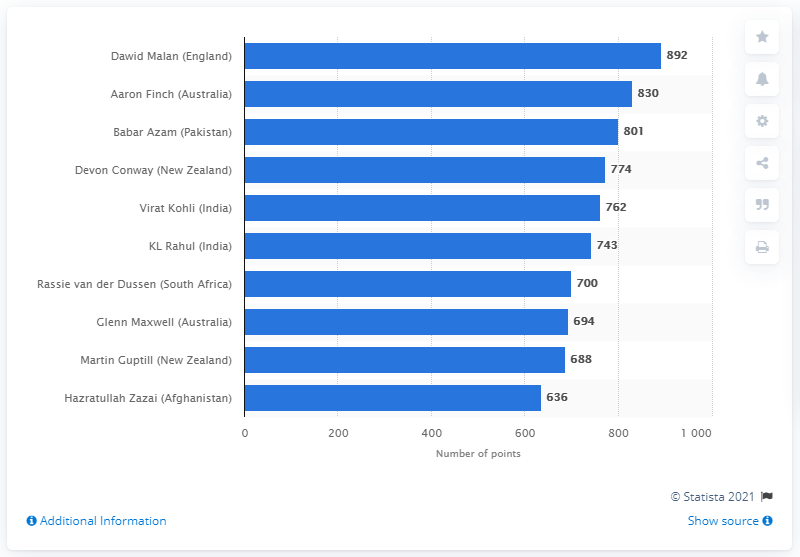Outline some significant characteristics in this image. Dawid Malan has 892 points. 